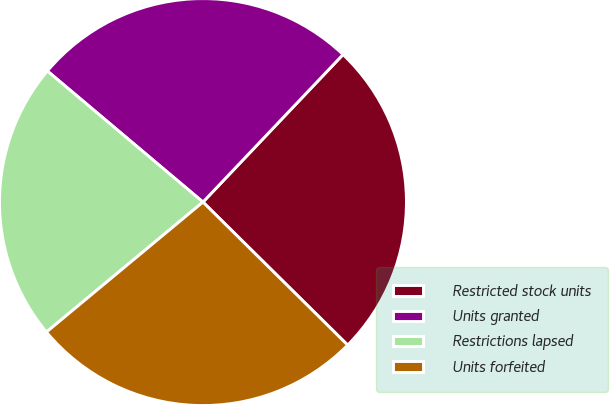Convert chart. <chart><loc_0><loc_0><loc_500><loc_500><pie_chart><fcel>Restricted stock units<fcel>Units granted<fcel>Restrictions lapsed<fcel>Units forfeited<nl><fcel>25.32%<fcel>25.94%<fcel>22.17%<fcel>26.56%<nl></chart> 